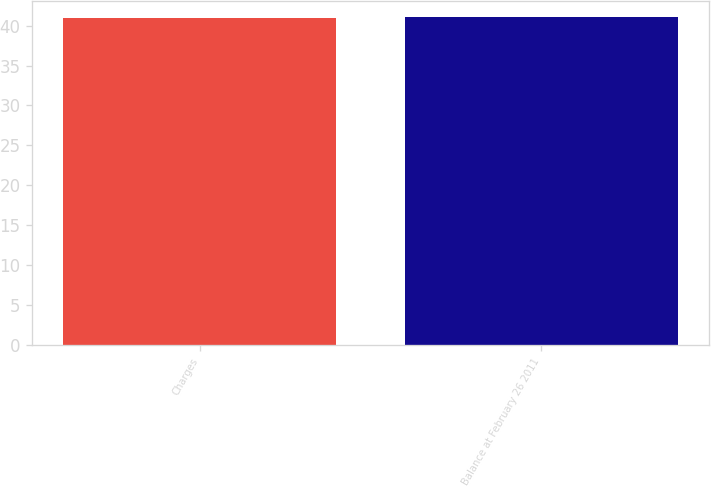Convert chart. <chart><loc_0><loc_0><loc_500><loc_500><bar_chart><fcel>Charges<fcel>Balance at February 26 2011<nl><fcel>41<fcel>41.1<nl></chart> 